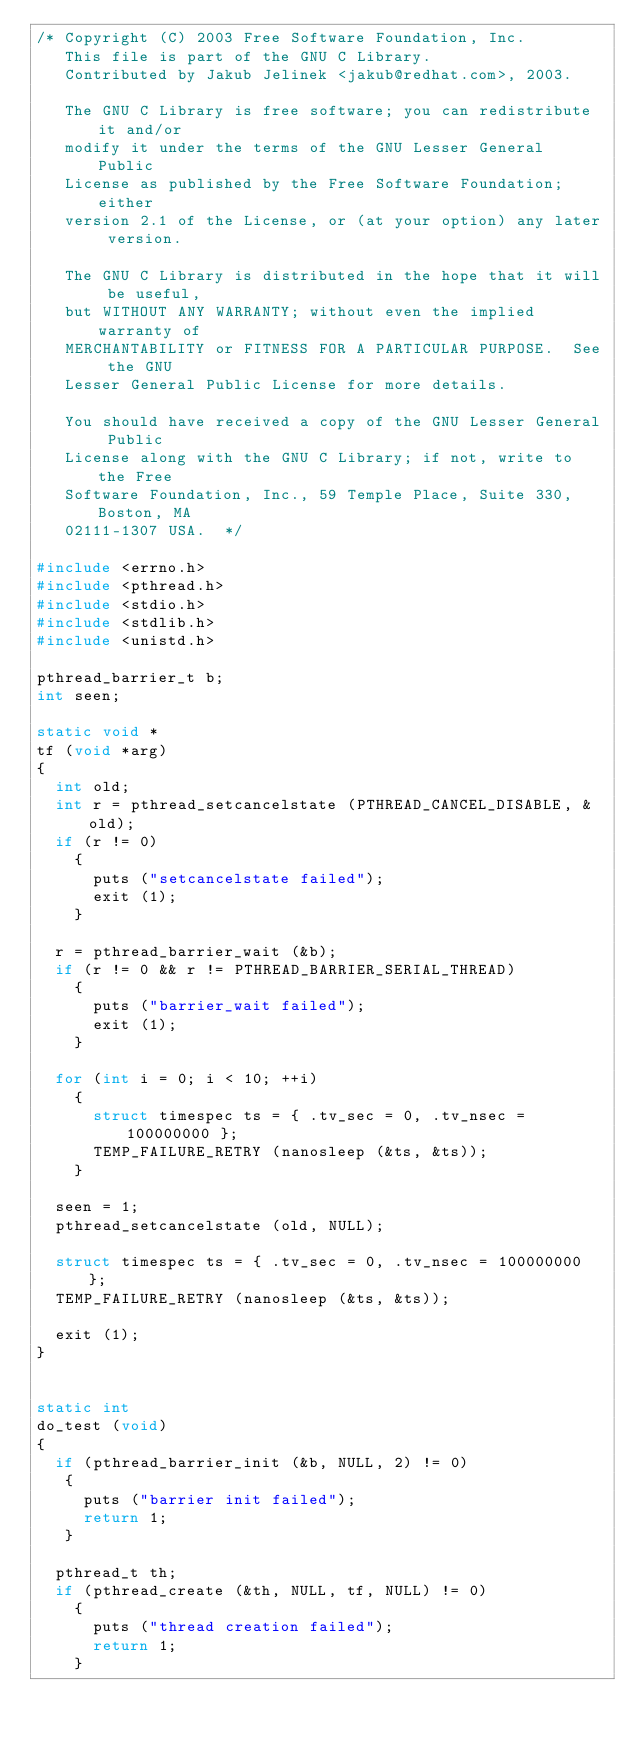<code> <loc_0><loc_0><loc_500><loc_500><_C_>/* Copyright (C) 2003 Free Software Foundation, Inc.
   This file is part of the GNU C Library.
   Contributed by Jakub Jelinek <jakub@redhat.com>, 2003.

   The GNU C Library is free software; you can redistribute it and/or
   modify it under the terms of the GNU Lesser General Public
   License as published by the Free Software Foundation; either
   version 2.1 of the License, or (at your option) any later version.

   The GNU C Library is distributed in the hope that it will be useful,
   but WITHOUT ANY WARRANTY; without even the implied warranty of
   MERCHANTABILITY or FITNESS FOR A PARTICULAR PURPOSE.  See the GNU
   Lesser General Public License for more details.

   You should have received a copy of the GNU Lesser General Public
   License along with the GNU C Library; if not, write to the Free
   Software Foundation, Inc., 59 Temple Place, Suite 330, Boston, MA
   02111-1307 USA.  */

#include <errno.h>
#include <pthread.h>
#include <stdio.h>
#include <stdlib.h>
#include <unistd.h>

pthread_barrier_t b;
int seen;

static void *
tf (void *arg)
{
  int old;
  int r = pthread_setcancelstate (PTHREAD_CANCEL_DISABLE, &old);
  if (r != 0)
    {
      puts ("setcancelstate failed");
      exit (1);
    }

  r = pthread_barrier_wait (&b);
  if (r != 0 && r != PTHREAD_BARRIER_SERIAL_THREAD)
    {
      puts ("barrier_wait failed");
      exit (1);
    }

  for (int i = 0; i < 10; ++i)
    {
      struct timespec ts = { .tv_sec = 0, .tv_nsec = 100000000 };
      TEMP_FAILURE_RETRY (nanosleep (&ts, &ts));
    }

  seen = 1;
  pthread_setcancelstate (old, NULL);

  struct timespec ts = { .tv_sec = 0, .tv_nsec = 100000000 };
  TEMP_FAILURE_RETRY (nanosleep (&ts, &ts));

  exit (1);
}


static int
do_test (void)
{
  if (pthread_barrier_init (&b, NULL, 2) != 0)
   {
     puts ("barrier init failed");
     return 1;
   }

  pthread_t th;
  if (pthread_create (&th, NULL, tf, NULL) != 0)
    {
      puts ("thread creation failed");
      return 1;
    }
</code> 